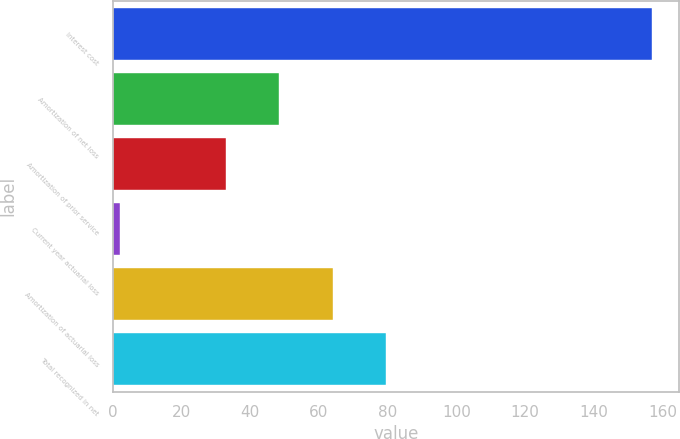<chart> <loc_0><loc_0><loc_500><loc_500><bar_chart><fcel>Interest cost<fcel>Amortization of net loss<fcel>Amortization of prior service<fcel>Current year actuarial loss<fcel>Amortization of actuarial loss<fcel>Total recognized in net<nl><fcel>157<fcel>48.5<fcel>33<fcel>2<fcel>64<fcel>79.5<nl></chart> 